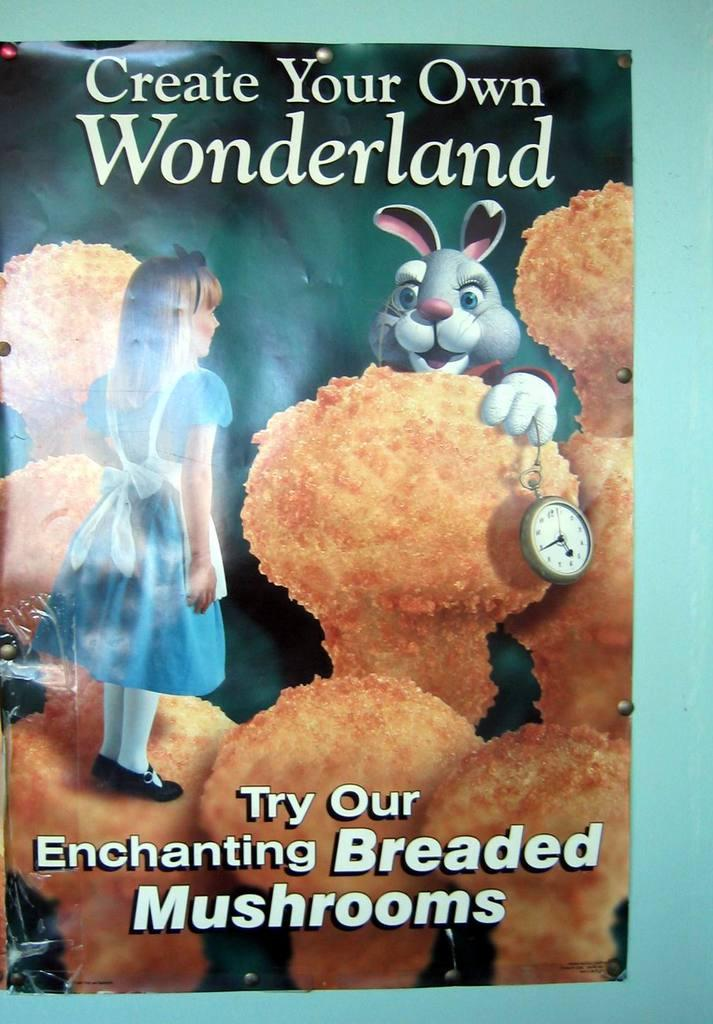<image>
Provide a brief description of the given image. A book named Create Your Own World Wonderland. 